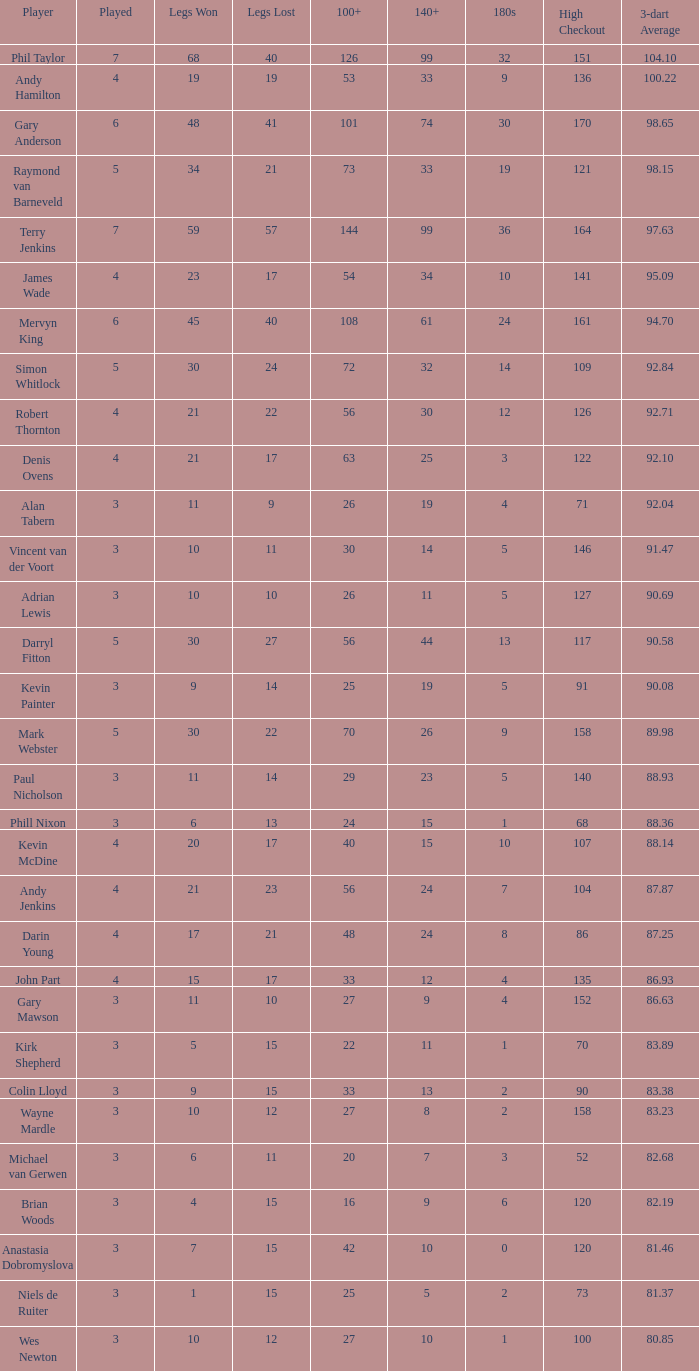What is the highest number of legs ever lost? 57.0. 